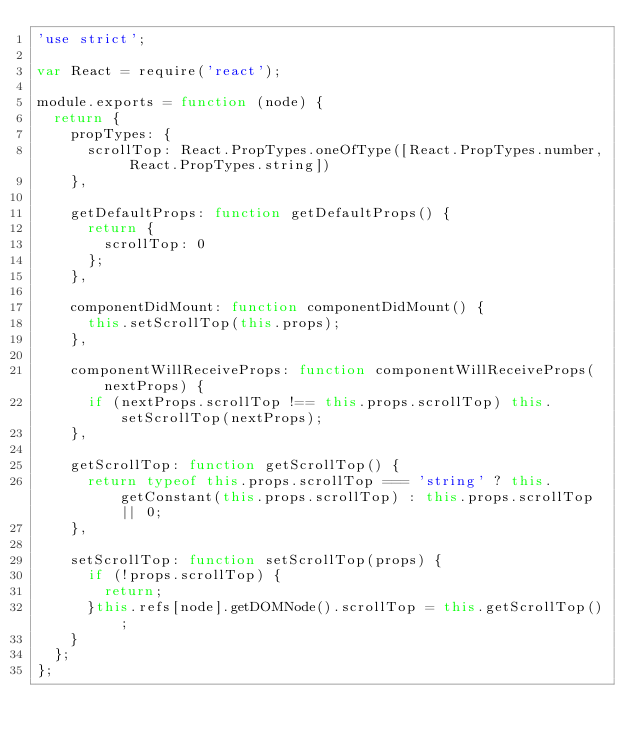Convert code to text. <code><loc_0><loc_0><loc_500><loc_500><_JavaScript_>'use strict';

var React = require('react');

module.exports = function (node) {
  return {
    propTypes: {
      scrollTop: React.PropTypes.oneOfType([React.PropTypes.number, React.PropTypes.string])
    },

    getDefaultProps: function getDefaultProps() {
      return {
        scrollTop: 0
      };
    },

    componentDidMount: function componentDidMount() {
      this.setScrollTop(this.props);
    },

    componentWillReceiveProps: function componentWillReceiveProps(nextProps) {
      if (nextProps.scrollTop !== this.props.scrollTop) this.setScrollTop(nextProps);
    },

    getScrollTop: function getScrollTop() {
      return typeof this.props.scrollTop === 'string' ? this.getConstant(this.props.scrollTop) : this.props.scrollTop || 0;
    },

    setScrollTop: function setScrollTop(props) {
      if (!props.scrollTop) {
        return;
      }this.refs[node].getDOMNode().scrollTop = this.getScrollTop();
    }
  };
};</code> 